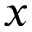Convert formula to latex. <formula><loc_0><loc_0><loc_500><loc_500>x</formula> 